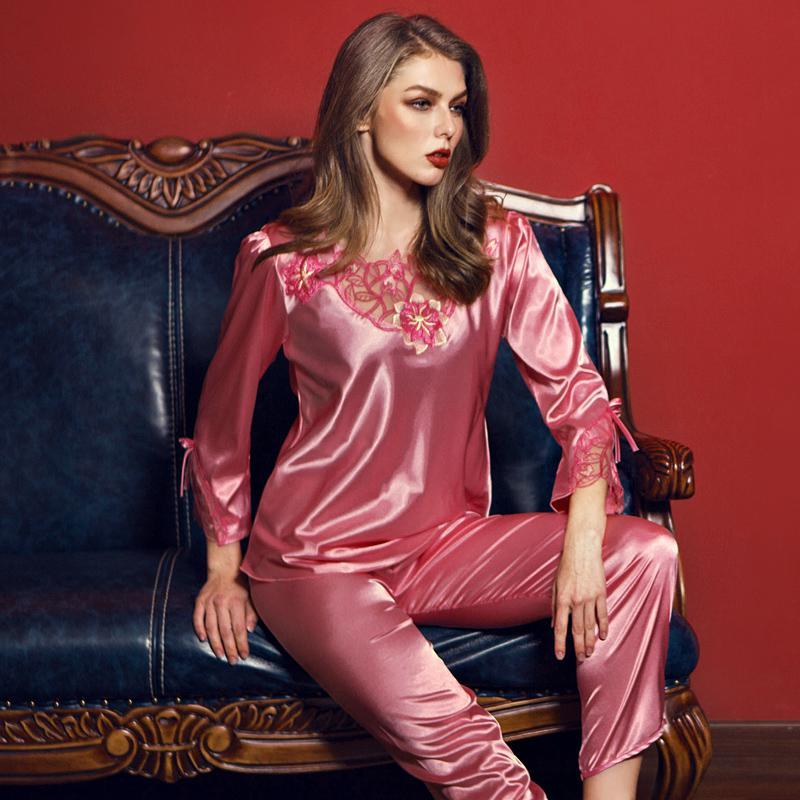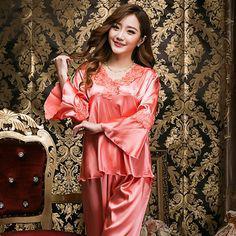The first image is the image on the left, the second image is the image on the right. Evaluate the accuracy of this statement regarding the images: "In one of the images, the girl is sitting down". Is it true? Answer yes or no. Yes. The first image is the image on the left, the second image is the image on the right. Given the left and right images, does the statement "One woman is sitting on something." hold true? Answer yes or no. Yes. 